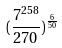Convert formula to latex. <formula><loc_0><loc_0><loc_500><loc_500>( \frac { 7 ^ { 2 5 8 } } { 2 7 0 } ) ^ { \frac { 6 } { 5 0 } }</formula> 